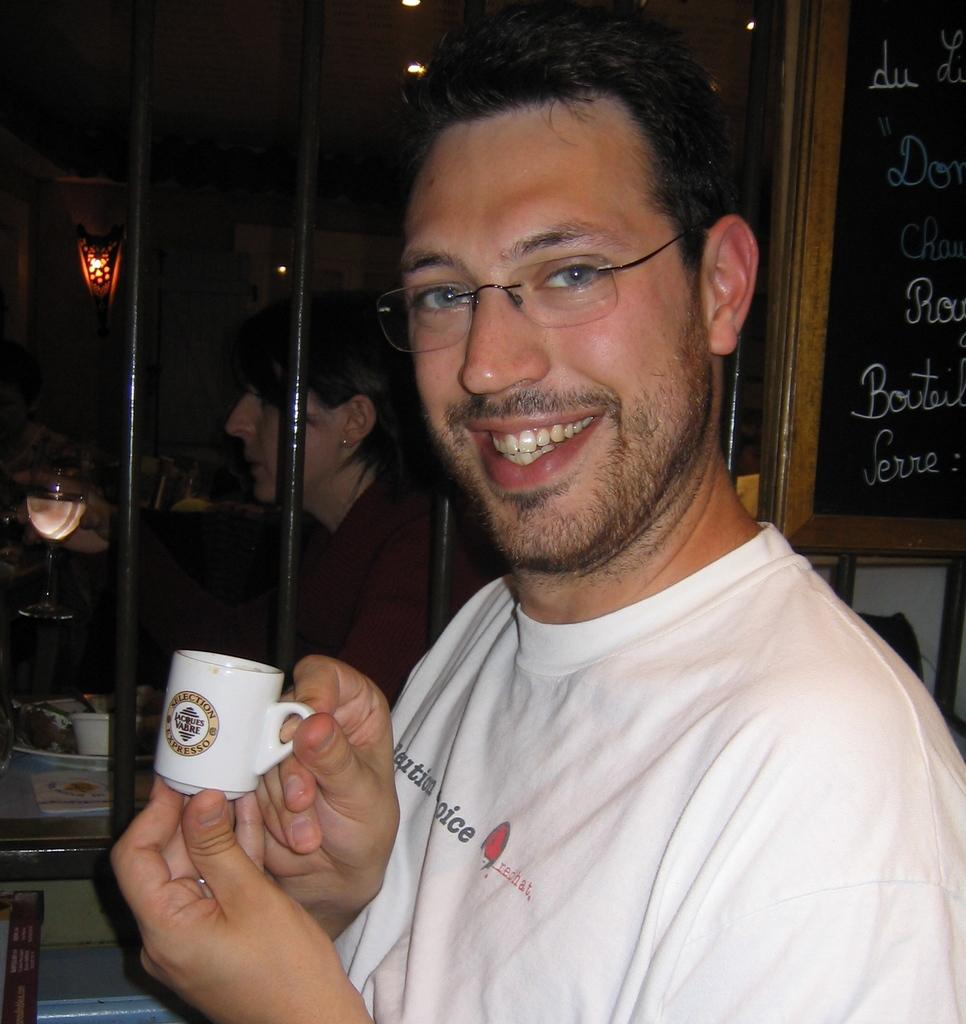What is present in the image? There is a man in the image. What is the man doing in the image? The man is standing in the image. What object is the man holding in his hand? The man is holding a cup in his hand. What type of engine can be seen in the image? There is no engine present in the image; it features a man standing and holding a cup. What type of horse is visible in the image? There is no horse present in the image; it features a man standing and holding a cup. 